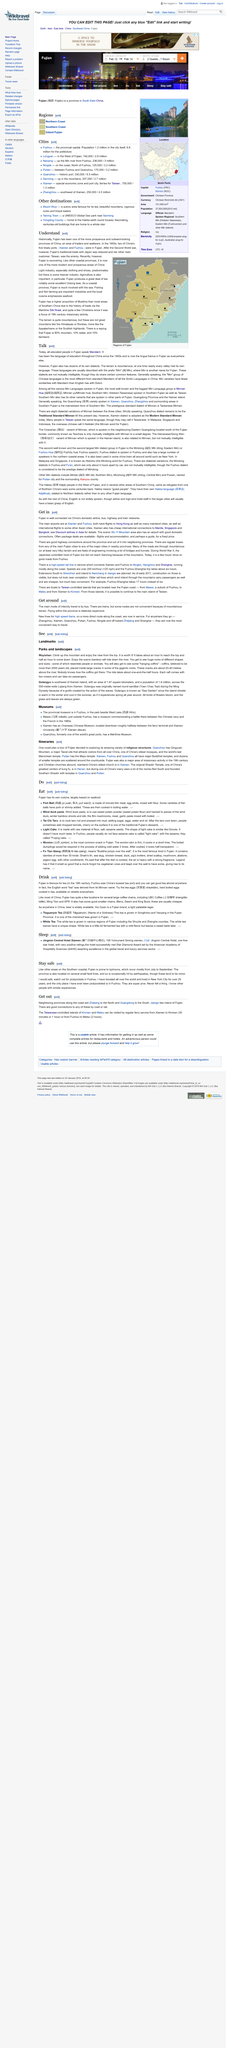List a handful of essential elements in this visual. In Fujian, Yes, Fujian people also speak Mandarin, which has been the language of education in China since the 1950s. Fujian is a language, and it also has dozens of its own dialects. It takes approximately an hour to reach the peak of Wuyishan Mountain. The Jingmin Central Hotel has 5 stars. 